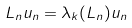Convert formula to latex. <formula><loc_0><loc_0><loc_500><loc_500>L _ { n } u _ { n } = \lambda _ { k } ( L _ { n } ) u _ { n }</formula> 